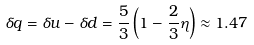Convert formula to latex. <formula><loc_0><loc_0><loc_500><loc_500>\delta q = \delta u - \delta d = \frac { 5 } { 3 } \left ( 1 - \frac { 2 } { 3 } \eta \right ) \approx 1 . 4 7</formula> 